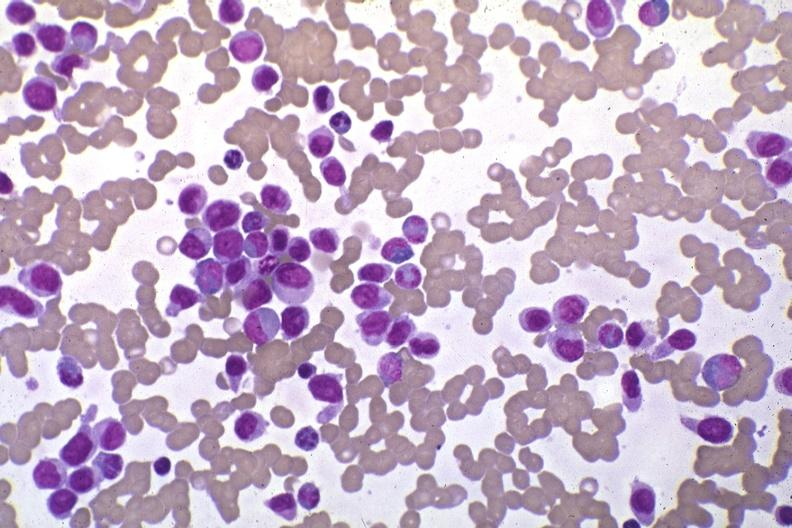do infarcts stain pleomorphic leukemic cells in peripheral blood prior to therapy?
Answer the question using a single word or phrase. No 